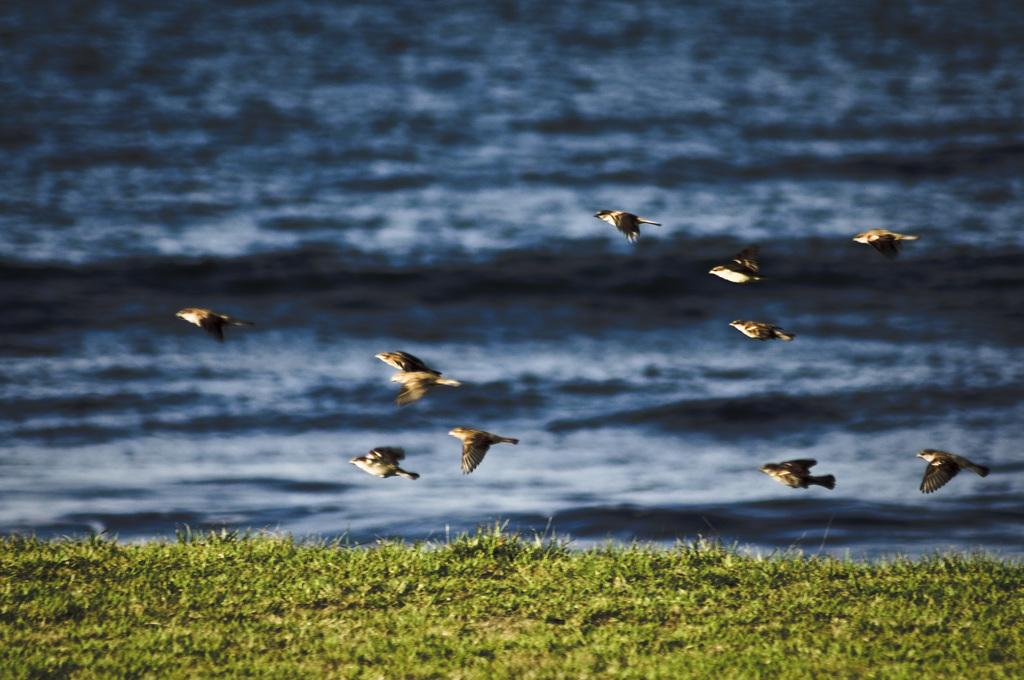What is happening in the image involving animals? There are birds flying in the image. What type of natural environment is depicted in the image? There is grass and water visible in the image. What does the brother's nerve do when he sees the birds in the image? There is no mention of a brother or his nerves in the image, so this question cannot be answered. 